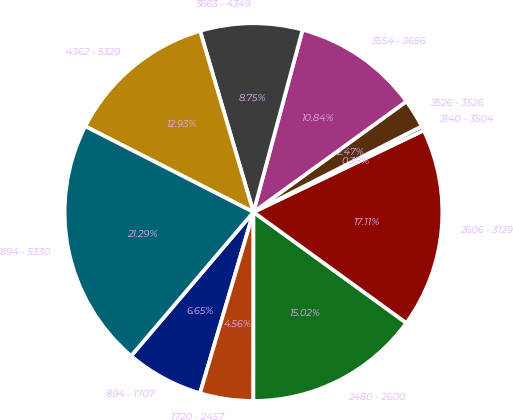<chart> <loc_0><loc_0><loc_500><loc_500><pie_chart><fcel>894 - 1707<fcel>1720 - 2457<fcel>2480 - 2600<fcel>2606 - 3129<fcel>3140 - 3504<fcel>3526 - 3526<fcel>3554 - 3656<fcel>3663 - 4349<fcel>4362 - 5329<fcel>894 - 5330<nl><fcel>6.65%<fcel>4.56%<fcel>15.02%<fcel>17.11%<fcel>0.38%<fcel>2.47%<fcel>10.84%<fcel>8.75%<fcel>12.93%<fcel>21.29%<nl></chart> 